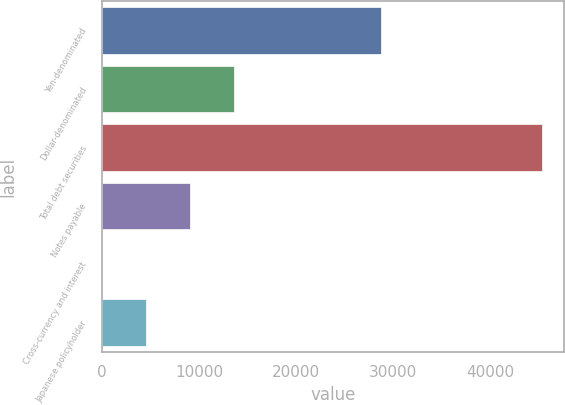Convert chart. <chart><loc_0><loc_0><loc_500><loc_500><bar_chart><fcel>Yen-denominated<fcel>Dollar-denominated<fcel>Total debt securities<fcel>Notes payable<fcel>Cross-currency and interest<fcel>Japanese policyholder<nl><fcel>28712<fcel>13612.4<fcel>45363<fcel>9076.6<fcel>5<fcel>4540.8<nl></chart> 